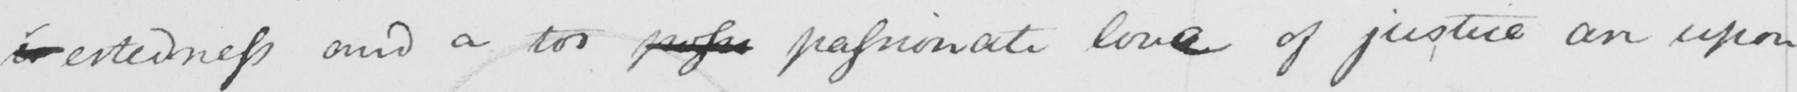What text is written in this handwritten line? -estedness and a too poss passionate love of justice on upon 